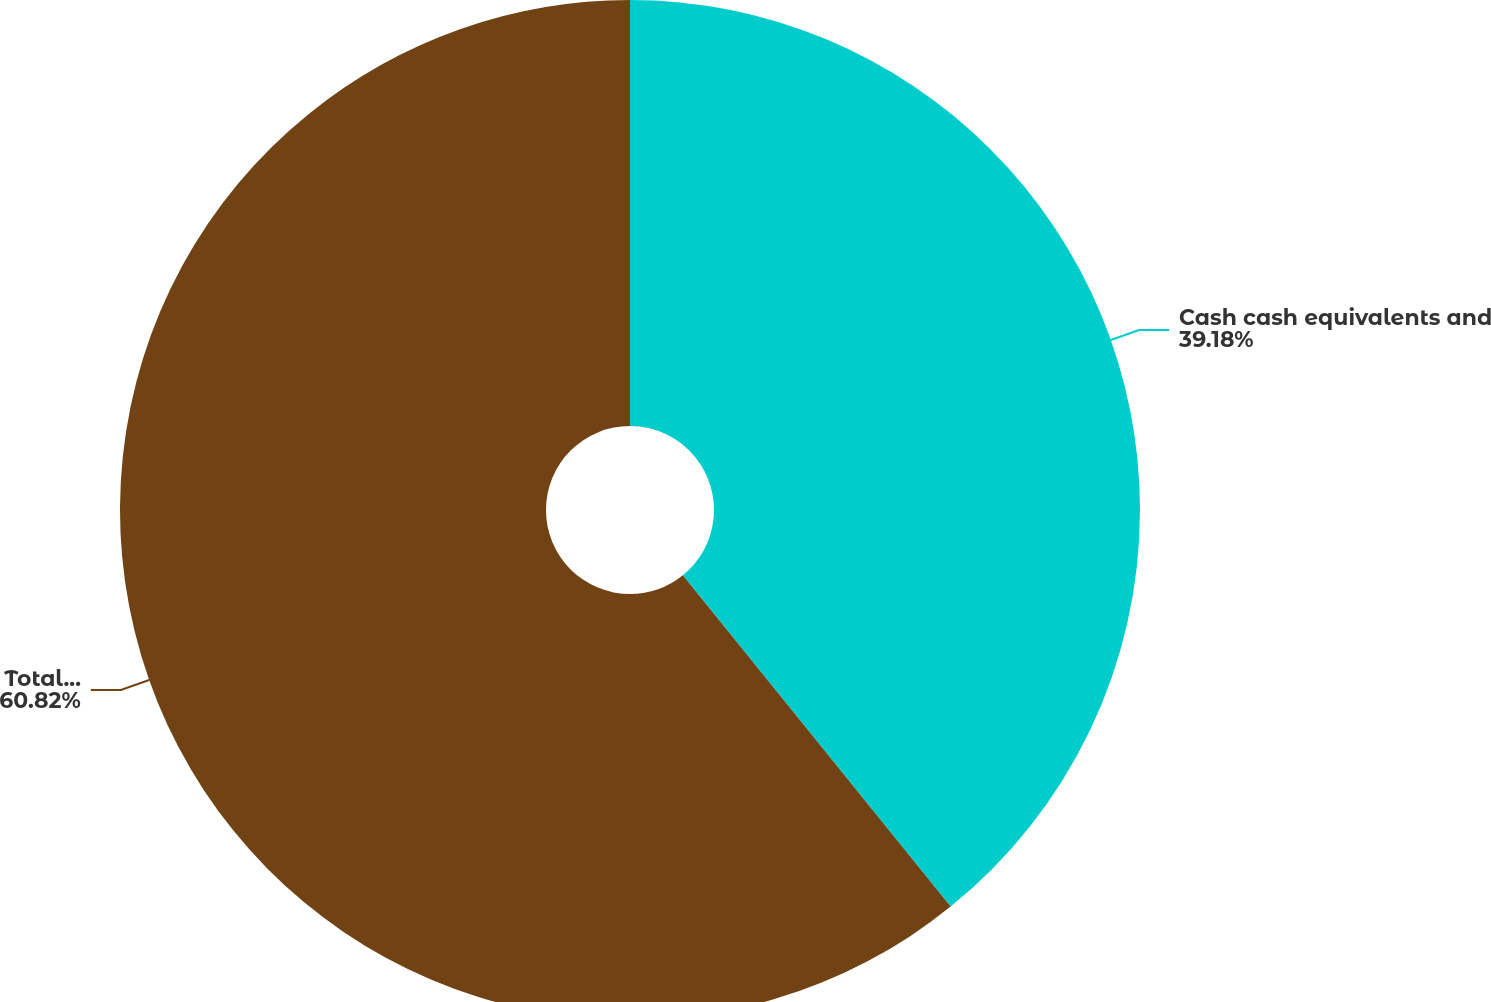<chart> <loc_0><loc_0><loc_500><loc_500><pie_chart><fcel>Cash cash equivalents and<fcel>Total assets<nl><fcel>39.18%<fcel>60.82%<nl></chart> 